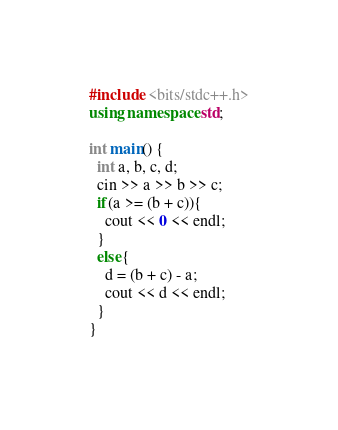Convert code to text. <code><loc_0><loc_0><loc_500><loc_500><_C++_>#include <bits/stdc++.h>
using namespace std;

int main() {
  int a, b, c, d;
  cin >> a >> b >> c;
  if(a >= (b + c)){
  	cout << 0 << endl;
  }
  else{
    d = (b + c) - a;
  	cout << d << endl;
  }
}
</code> 